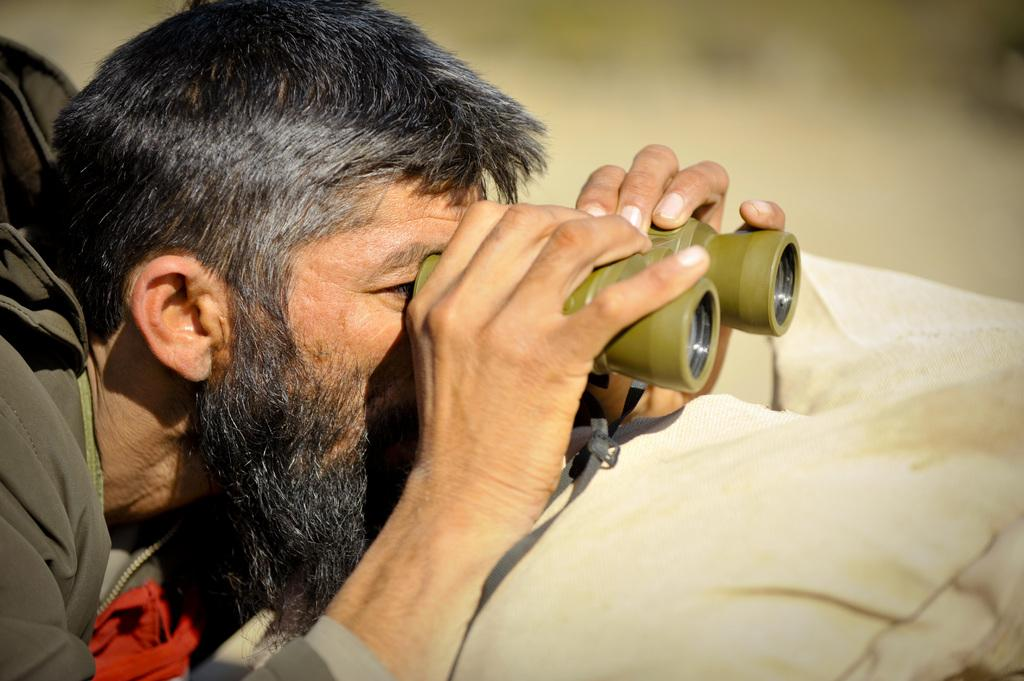Who is present in the image? There is a man in the image. What is the man holding in the image? The man is holding binoculars. What is located below the man's hand in the image? There is a cloth below the man's hand. Can you describe the background of the image? The background of the image is blurry. What type of jellyfish can be seen floating near the man in the image? There are no jellyfish present in the image; it only features a man holding binoculars with a cloth below his hand and a blurry background. 